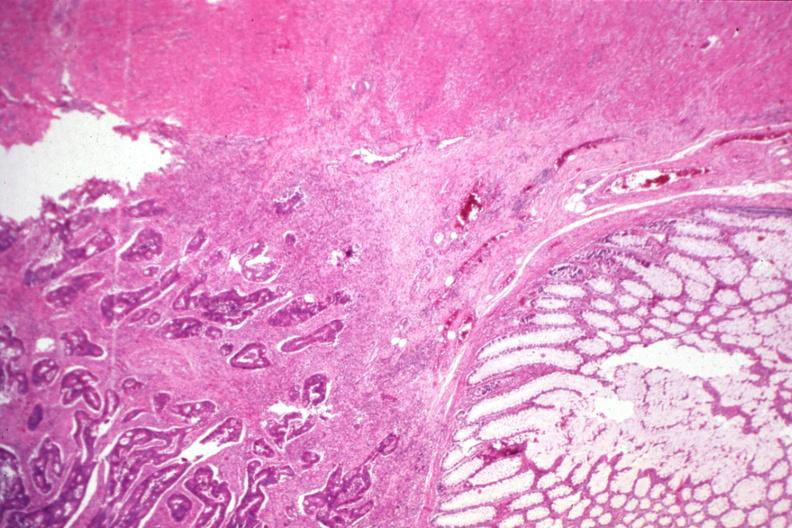does case of peritonitis slide show typical infiltrating adenocarcinoma and normal mucosa?
Answer the question using a single word or phrase. No 